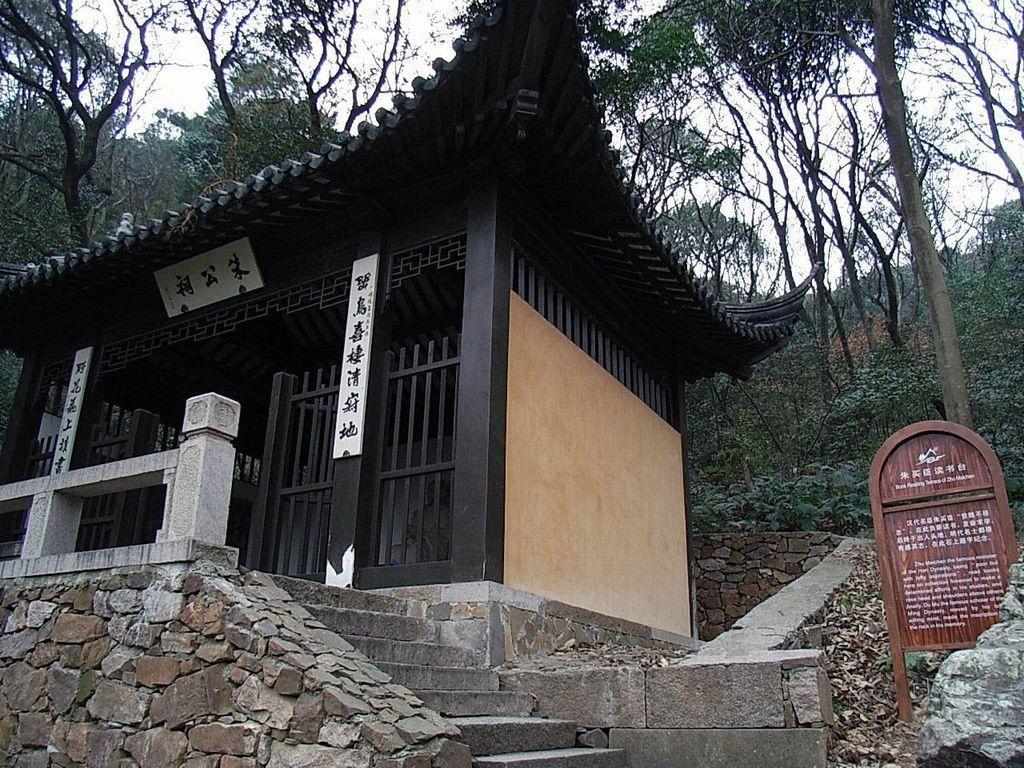In one or two sentences, can you explain what this image depicts? As we can see in the image there is a house, stairs, plants, trees and sky. 